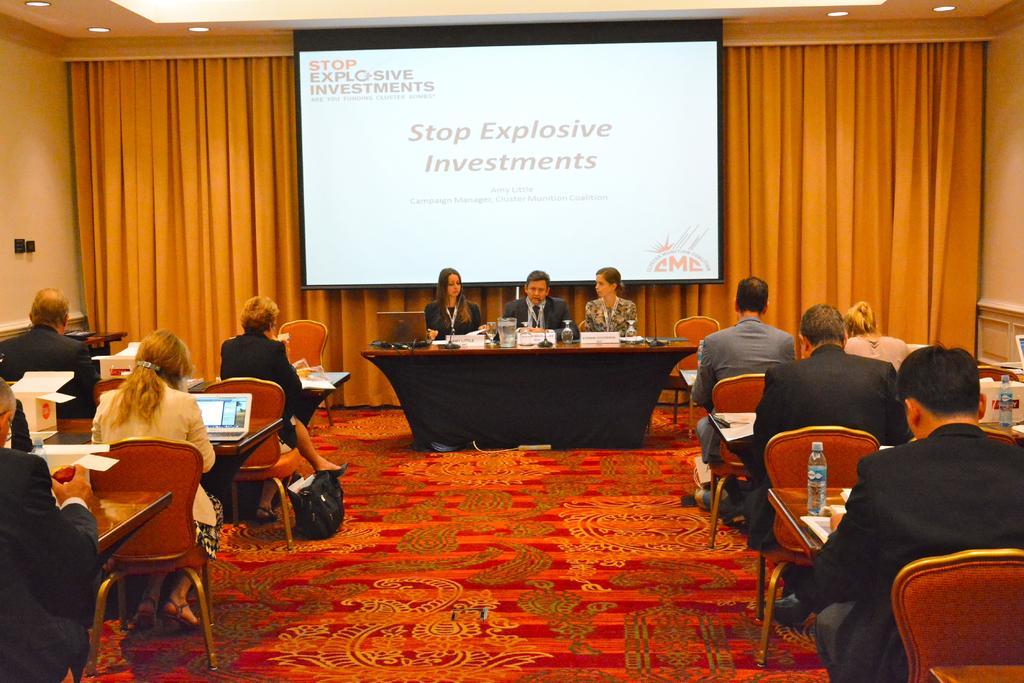Please provide a concise description of this image. The picture is clicked inside a conference hall where there are several people on the brown table with laptops in front of them. In the center of the image there are three people sitting on a black chair and there is a curtain in the background. 